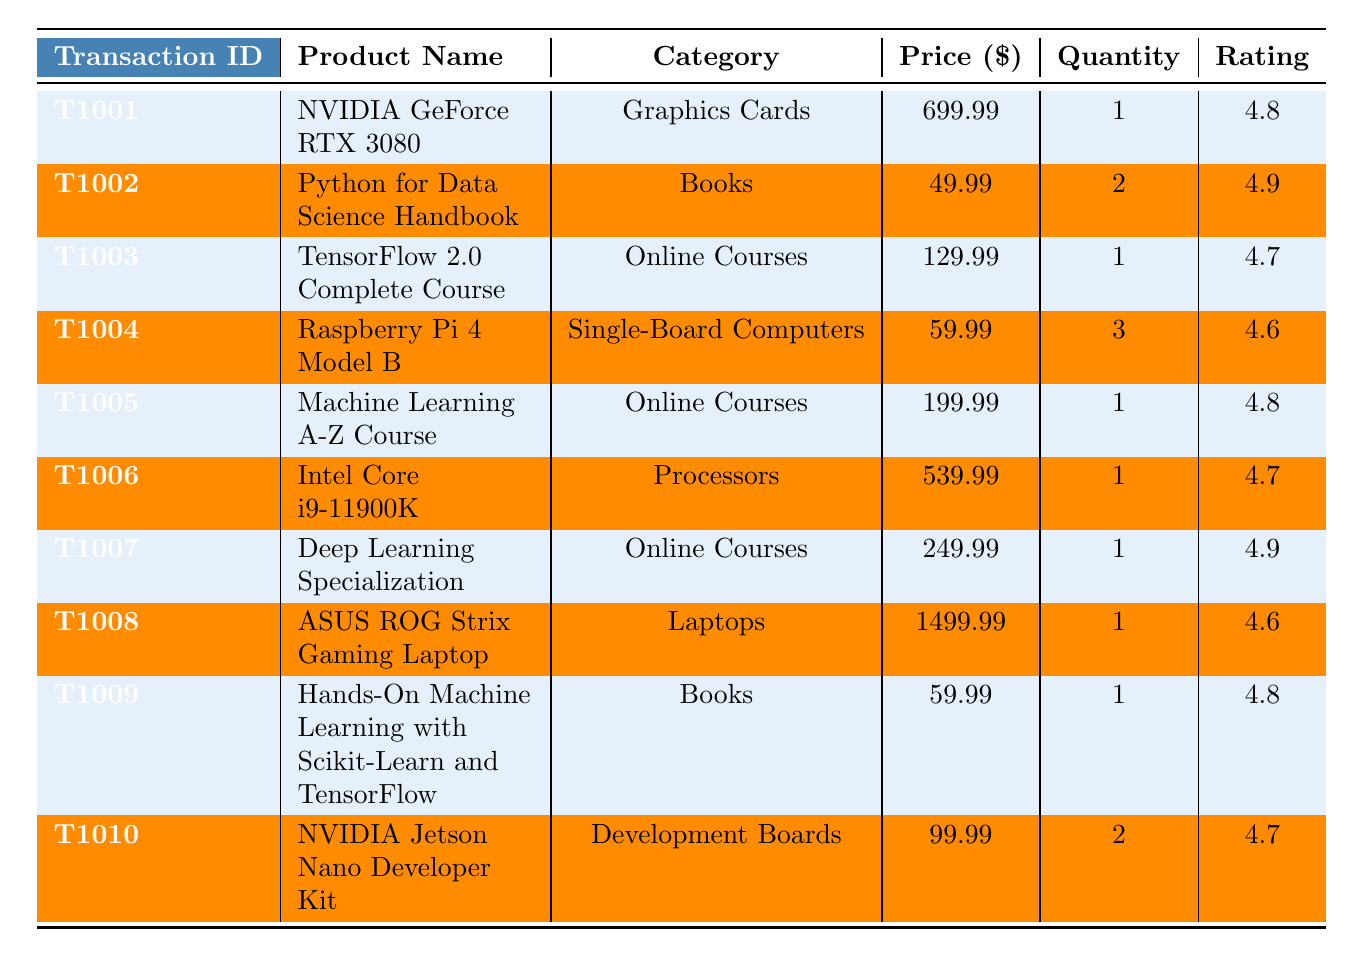What is the highest priced product in the table? By examining the price column, we see that the ASUS ROG Strix Gaming Laptop has the highest price at $1499.99.
Answer: $1499.99 How many transactions are in the dataset? The table lists 10 transactions, as we can count each row under the transactions section.
Answer: 10 What is the total quantity of products purchased for the transaction with ID T1004? For transaction T1004, the quantity column shows a value of 3, indicating that 3 units of Raspberry Pi 4 Model B were purchased.
Answer: 3 Which product has the highest customer rating? Looking at the rating column, we find that both the Python for Data Science Handbook and the Deep Learning Specialization have the highest rating of 4.9, so they share this status.
Answer: 4.9 What is the average price of the products in the Online Courses category? The products in this category are priced at $129.99 (TensorFlow 2.0 Complete Course), $199.99 (Machine Learning A-Z Course), and $249.99 (Deep Learning Specialization). The sum is $579.97; dividing this by 3 gives an average of $193.33.
Answer: $193.33 Did any customer use a Debit Card for their payment? From the payment method column, we see that both transactions (T1003 and T1007) were made using Debit Cards. Thus, the answer is yes.
Answer: Yes How many products had a rating of 4.6 or lower? By examining the ratings, we find that Raspberry Pi 4 Model B and ASUS ROG Strix Gaming Laptop have ratings of 4.6. Therefore, there are 2 products that meet this criterion.
Answer: 2 What is the total revenue generated from the transactions made with a Credit Card? The transactions with a Credit Card are T1001 ($699.99), T1004 ($59.99), T1006 ($539.99), T1008 ($1499.99), and T1010 ($199.98). Summing these gives $2999.94 as the total revenue from Credit Card transactions.
Answer: $2999.94 Which product category has the most transactions? Reviewing the data, we see 3 entries for Online Courses (T1003, T1005, T1007), while other categories have fewer than this. Thus, Online Courses is the most represented category.
Answer: Online Courses What is the difference in price between the most and least expensive product? The most expensive product is the ASUS ROG Strix Gaming Laptop at $1499.99 and the least expensive is the Python for Data Science Handbook at $49.99. The difference is $1499.99 - $49.99 = $1450.00.
Answer: $1450.00 